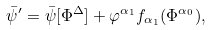Convert formula to latex. <formula><loc_0><loc_0><loc_500><loc_500>\bar { \psi } ^ { \prime } = \bar { \psi } [ \Phi ^ { \Delta } ] + \varphi ^ { \alpha _ { 1 } } f _ { \alpha _ { 1 } } ( \Phi ^ { \alpha _ { 0 } } ) ,</formula> 